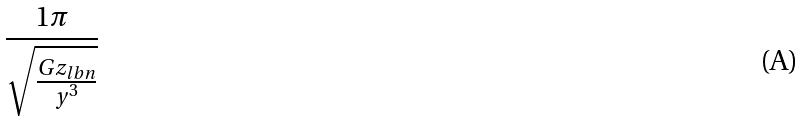<formula> <loc_0><loc_0><loc_500><loc_500>\frac { 1 \pi } { \sqrt { \frac { G z _ { l b n } } { y ^ { 3 } } } }</formula> 